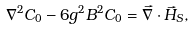<formula> <loc_0><loc_0><loc_500><loc_500>\nabla ^ { 2 } C _ { 0 } - 6 g ^ { 2 } B ^ { 2 } C _ { 0 } = \vec { \nabla } \cdot \vec { H } _ { S } ,</formula> 